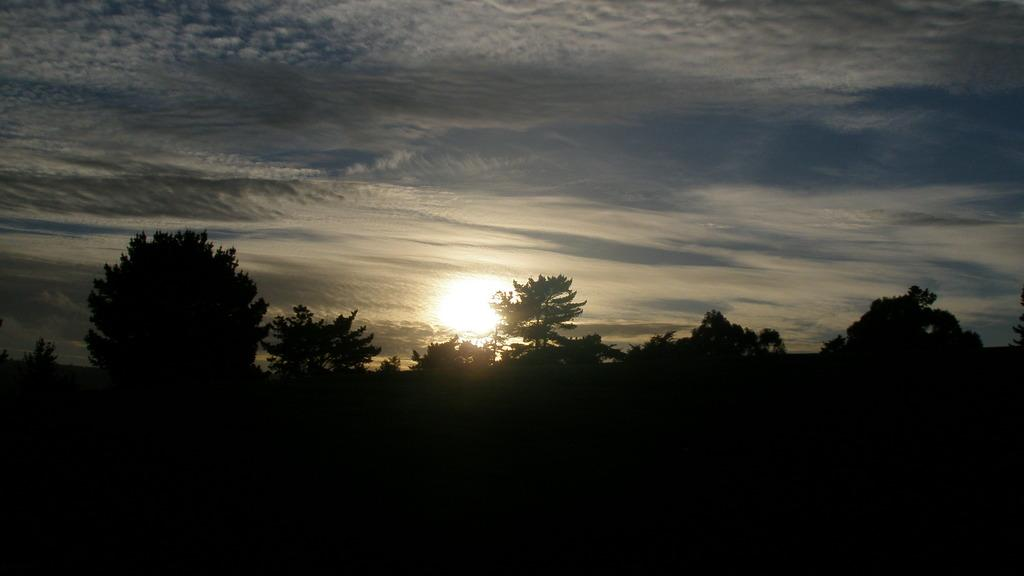What is located in the center of the image? There are trees in the center of the image. What is the condition of the sky in the image? The sky is cloudy in the image. What type of government is depicted in the image? There is no depiction of a government in the image; it features trees and a cloudy sky. Can you tell me how many cribs are visible in the image? There are no cribs present in the image. 